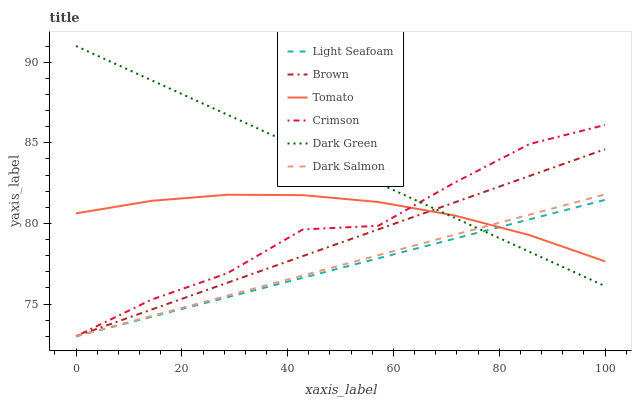Does Light Seafoam have the minimum area under the curve?
Answer yes or no. Yes. Does Dark Green have the maximum area under the curve?
Answer yes or no. Yes. Does Brown have the minimum area under the curve?
Answer yes or no. No. Does Brown have the maximum area under the curve?
Answer yes or no. No. Is Dark Green the smoothest?
Answer yes or no. Yes. Is Crimson the roughest?
Answer yes or no. Yes. Is Brown the smoothest?
Answer yes or no. No. Is Brown the roughest?
Answer yes or no. No. Does Brown have the lowest value?
Answer yes or no. Yes. Does Dark Green have the lowest value?
Answer yes or no. No. Does Dark Green have the highest value?
Answer yes or no. Yes. Does Brown have the highest value?
Answer yes or no. No. Does Dark Green intersect Crimson?
Answer yes or no. Yes. Is Dark Green less than Crimson?
Answer yes or no. No. Is Dark Green greater than Crimson?
Answer yes or no. No. 